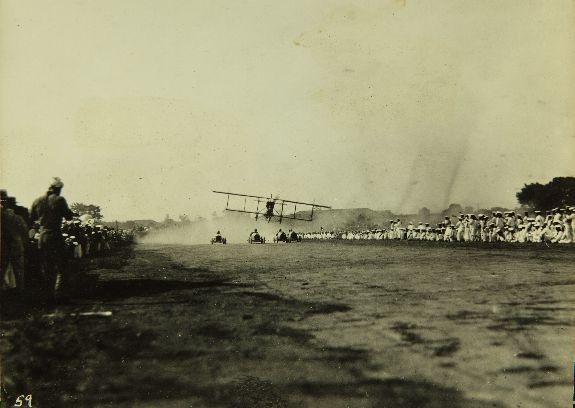Describe the objects in this image and their specific colors. I can see people in tan, black, and gray tones, people in tan, black, gray, and darkgreen tones, airplane in tan, black, and gray tones, people in tan, black, and gray tones, and people in tan, beige, and gray tones in this image. 